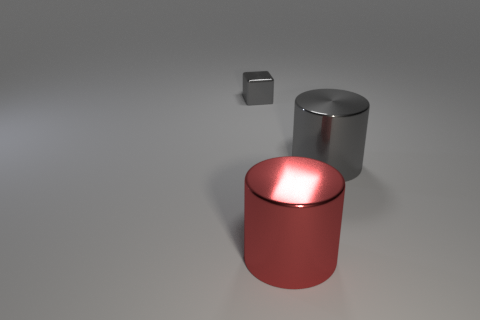What is the size of the gray shiny cylinder? The gray shiny cylinder appears to be of a medium size in comparison to its surroundings, featuring a sleek metallic finish and reflecting the ambient light, which suggests it may be made of a material like polished steel or aluminum. 